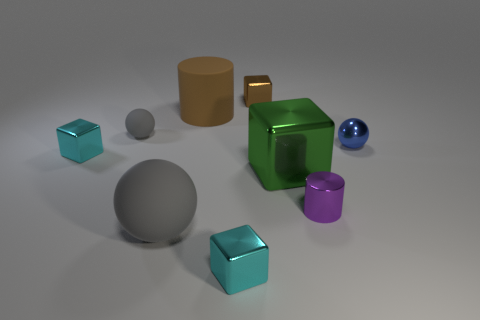Subtract all small metal blocks. How many blocks are left? 1 Subtract all green blocks. How many gray balls are left? 2 Subtract all green blocks. How many blocks are left? 3 Subtract 1 cylinders. How many cylinders are left? 1 Subtract all cylinders. How many objects are left? 7 Add 2 big brown objects. How many big brown objects are left? 3 Add 3 small shiny objects. How many small shiny objects exist? 8 Subtract 0 green spheres. How many objects are left? 9 Subtract all gray balls. Subtract all red blocks. How many balls are left? 1 Subtract all cyan metallic blocks. Subtract all tiny purple metal cylinders. How many objects are left? 6 